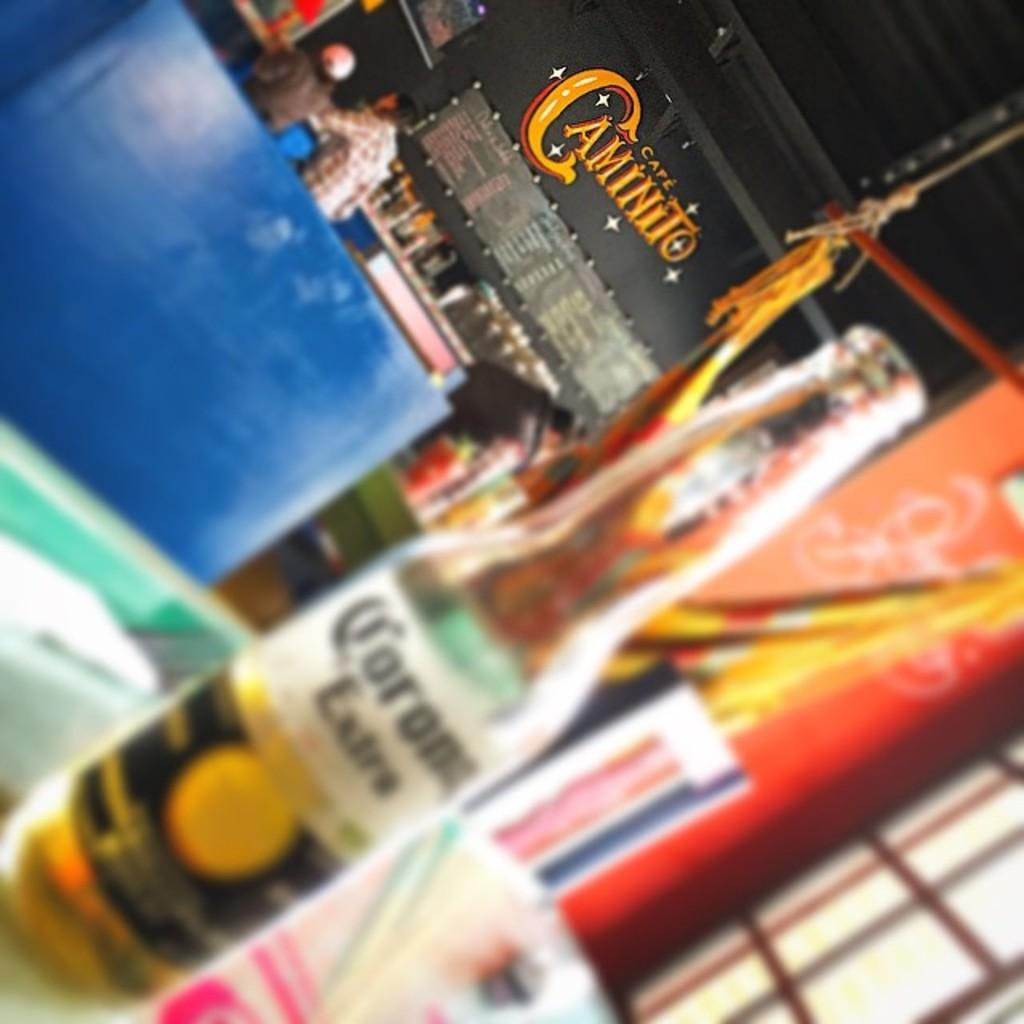<image>
Present a compact description of the photo's key features. On a table, a blurred photo of a carona is seen with a Caminito sign in the background. 